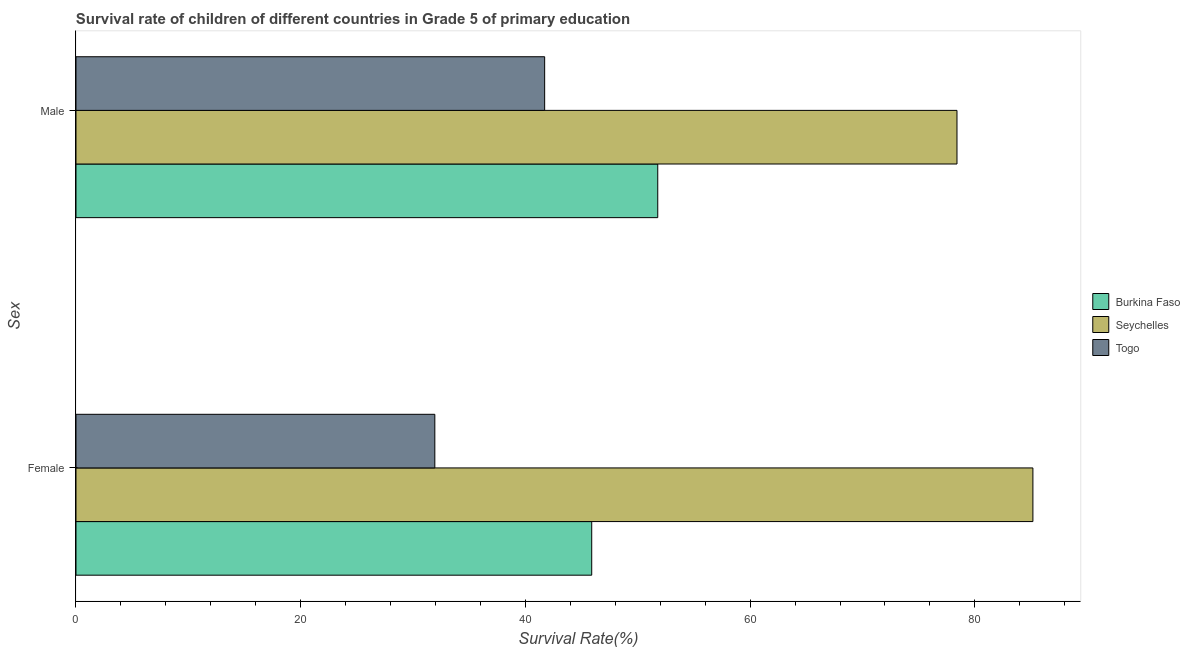How many different coloured bars are there?
Provide a short and direct response. 3. How many groups of bars are there?
Keep it short and to the point. 2. Are the number of bars on each tick of the Y-axis equal?
Your response must be concise. Yes. How many bars are there on the 2nd tick from the top?
Give a very brief answer. 3. What is the survival rate of female students in primary education in Seychelles?
Your answer should be very brief. 85.17. Across all countries, what is the maximum survival rate of female students in primary education?
Ensure brevity in your answer.  85.17. Across all countries, what is the minimum survival rate of male students in primary education?
Offer a very short reply. 41.71. In which country was the survival rate of female students in primary education maximum?
Provide a short and direct response. Seychelles. In which country was the survival rate of female students in primary education minimum?
Ensure brevity in your answer.  Togo. What is the total survival rate of male students in primary education in the graph?
Keep it short and to the point. 171.9. What is the difference between the survival rate of male students in primary education in Seychelles and that in Togo?
Your answer should be very brief. 36.7. What is the difference between the survival rate of male students in primary education in Togo and the survival rate of female students in primary education in Seychelles?
Provide a succinct answer. -43.46. What is the average survival rate of male students in primary education per country?
Make the answer very short. 57.3. What is the difference between the survival rate of female students in primary education and survival rate of male students in primary education in Burkina Faso?
Provide a succinct answer. -5.88. What is the ratio of the survival rate of female students in primary education in Seychelles to that in Togo?
Offer a very short reply. 2.67. Is the survival rate of female students in primary education in Burkina Faso less than that in Seychelles?
Your response must be concise. Yes. What does the 3rd bar from the top in Female represents?
Give a very brief answer. Burkina Faso. What does the 1st bar from the bottom in Female represents?
Your response must be concise. Burkina Faso. How many bars are there?
Your answer should be compact. 6. Are all the bars in the graph horizontal?
Your answer should be very brief. Yes. Does the graph contain any zero values?
Offer a very short reply. No. Does the graph contain grids?
Offer a very short reply. No. How many legend labels are there?
Give a very brief answer. 3. What is the title of the graph?
Provide a short and direct response. Survival rate of children of different countries in Grade 5 of primary education. What is the label or title of the X-axis?
Your answer should be very brief. Survival Rate(%). What is the label or title of the Y-axis?
Offer a very short reply. Sex. What is the Survival Rate(%) in Burkina Faso in Female?
Keep it short and to the point. 45.9. What is the Survival Rate(%) in Seychelles in Female?
Your response must be concise. 85.17. What is the Survival Rate(%) of Togo in Female?
Offer a very short reply. 31.94. What is the Survival Rate(%) of Burkina Faso in Male?
Your response must be concise. 51.78. What is the Survival Rate(%) of Seychelles in Male?
Offer a terse response. 78.41. What is the Survival Rate(%) of Togo in Male?
Provide a short and direct response. 41.71. Across all Sex, what is the maximum Survival Rate(%) in Burkina Faso?
Provide a succinct answer. 51.78. Across all Sex, what is the maximum Survival Rate(%) of Seychelles?
Provide a succinct answer. 85.17. Across all Sex, what is the maximum Survival Rate(%) in Togo?
Keep it short and to the point. 41.71. Across all Sex, what is the minimum Survival Rate(%) in Burkina Faso?
Make the answer very short. 45.9. Across all Sex, what is the minimum Survival Rate(%) of Seychelles?
Offer a terse response. 78.41. Across all Sex, what is the minimum Survival Rate(%) in Togo?
Keep it short and to the point. 31.94. What is the total Survival Rate(%) in Burkina Faso in the graph?
Keep it short and to the point. 97.68. What is the total Survival Rate(%) of Seychelles in the graph?
Make the answer very short. 163.58. What is the total Survival Rate(%) of Togo in the graph?
Your answer should be very brief. 73.65. What is the difference between the Survival Rate(%) in Burkina Faso in Female and that in Male?
Your answer should be very brief. -5.88. What is the difference between the Survival Rate(%) in Seychelles in Female and that in Male?
Your answer should be compact. 6.76. What is the difference between the Survival Rate(%) in Togo in Female and that in Male?
Provide a succinct answer. -9.78. What is the difference between the Survival Rate(%) of Burkina Faso in Female and the Survival Rate(%) of Seychelles in Male?
Provide a short and direct response. -32.51. What is the difference between the Survival Rate(%) in Burkina Faso in Female and the Survival Rate(%) in Togo in Male?
Offer a terse response. 4.19. What is the difference between the Survival Rate(%) in Seychelles in Female and the Survival Rate(%) in Togo in Male?
Your answer should be very brief. 43.46. What is the average Survival Rate(%) in Burkina Faso per Sex?
Ensure brevity in your answer.  48.84. What is the average Survival Rate(%) of Seychelles per Sex?
Give a very brief answer. 81.79. What is the average Survival Rate(%) in Togo per Sex?
Keep it short and to the point. 36.83. What is the difference between the Survival Rate(%) of Burkina Faso and Survival Rate(%) of Seychelles in Female?
Give a very brief answer. -39.27. What is the difference between the Survival Rate(%) in Burkina Faso and Survival Rate(%) in Togo in Female?
Make the answer very short. 13.96. What is the difference between the Survival Rate(%) of Seychelles and Survival Rate(%) of Togo in Female?
Make the answer very short. 53.23. What is the difference between the Survival Rate(%) of Burkina Faso and Survival Rate(%) of Seychelles in Male?
Provide a succinct answer. -26.63. What is the difference between the Survival Rate(%) in Burkina Faso and Survival Rate(%) in Togo in Male?
Your answer should be very brief. 10.06. What is the difference between the Survival Rate(%) of Seychelles and Survival Rate(%) of Togo in Male?
Give a very brief answer. 36.7. What is the ratio of the Survival Rate(%) in Burkina Faso in Female to that in Male?
Make the answer very short. 0.89. What is the ratio of the Survival Rate(%) of Seychelles in Female to that in Male?
Make the answer very short. 1.09. What is the ratio of the Survival Rate(%) of Togo in Female to that in Male?
Keep it short and to the point. 0.77. What is the difference between the highest and the second highest Survival Rate(%) in Burkina Faso?
Offer a terse response. 5.88. What is the difference between the highest and the second highest Survival Rate(%) in Seychelles?
Make the answer very short. 6.76. What is the difference between the highest and the second highest Survival Rate(%) in Togo?
Offer a terse response. 9.78. What is the difference between the highest and the lowest Survival Rate(%) of Burkina Faso?
Your response must be concise. 5.88. What is the difference between the highest and the lowest Survival Rate(%) in Seychelles?
Ensure brevity in your answer.  6.76. What is the difference between the highest and the lowest Survival Rate(%) of Togo?
Make the answer very short. 9.78. 